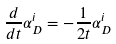<formula> <loc_0><loc_0><loc_500><loc_500>\frac { d } { d t } \alpha ^ { i } _ { D } = - \frac { 1 } { 2 t } \alpha ^ { i } _ { D }</formula> 